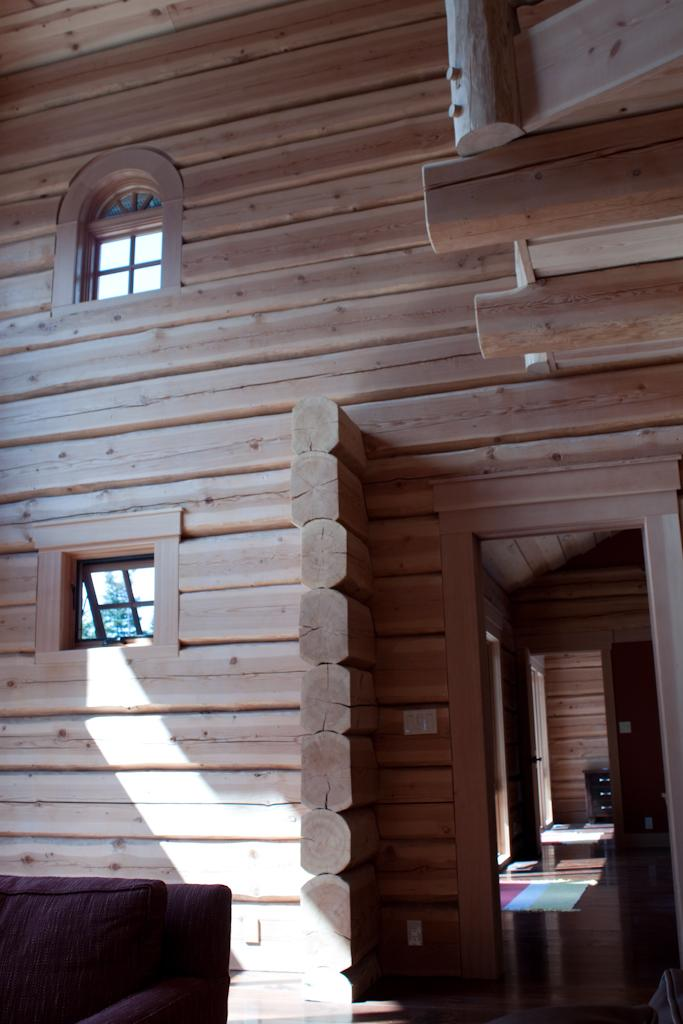What type of walls are present in the image? There are wooden walls in the image. What type of windows are present in the image? There are glass windows in the image. What type of entryways are present in the image? There are doors in the image. What type of seating is present at the bottom of the image? There is a couch at the bottom of the image. What type of surface is present under the objects in the image? There is a floor in the image. What type of floor covering is present in the image? There is a floor mat in the image. What type of objects can be seen in the image? There are objects visible in the image. How many times does the coat cry in the image? There is no coat present in the image, and therefore no such action can be observed. 